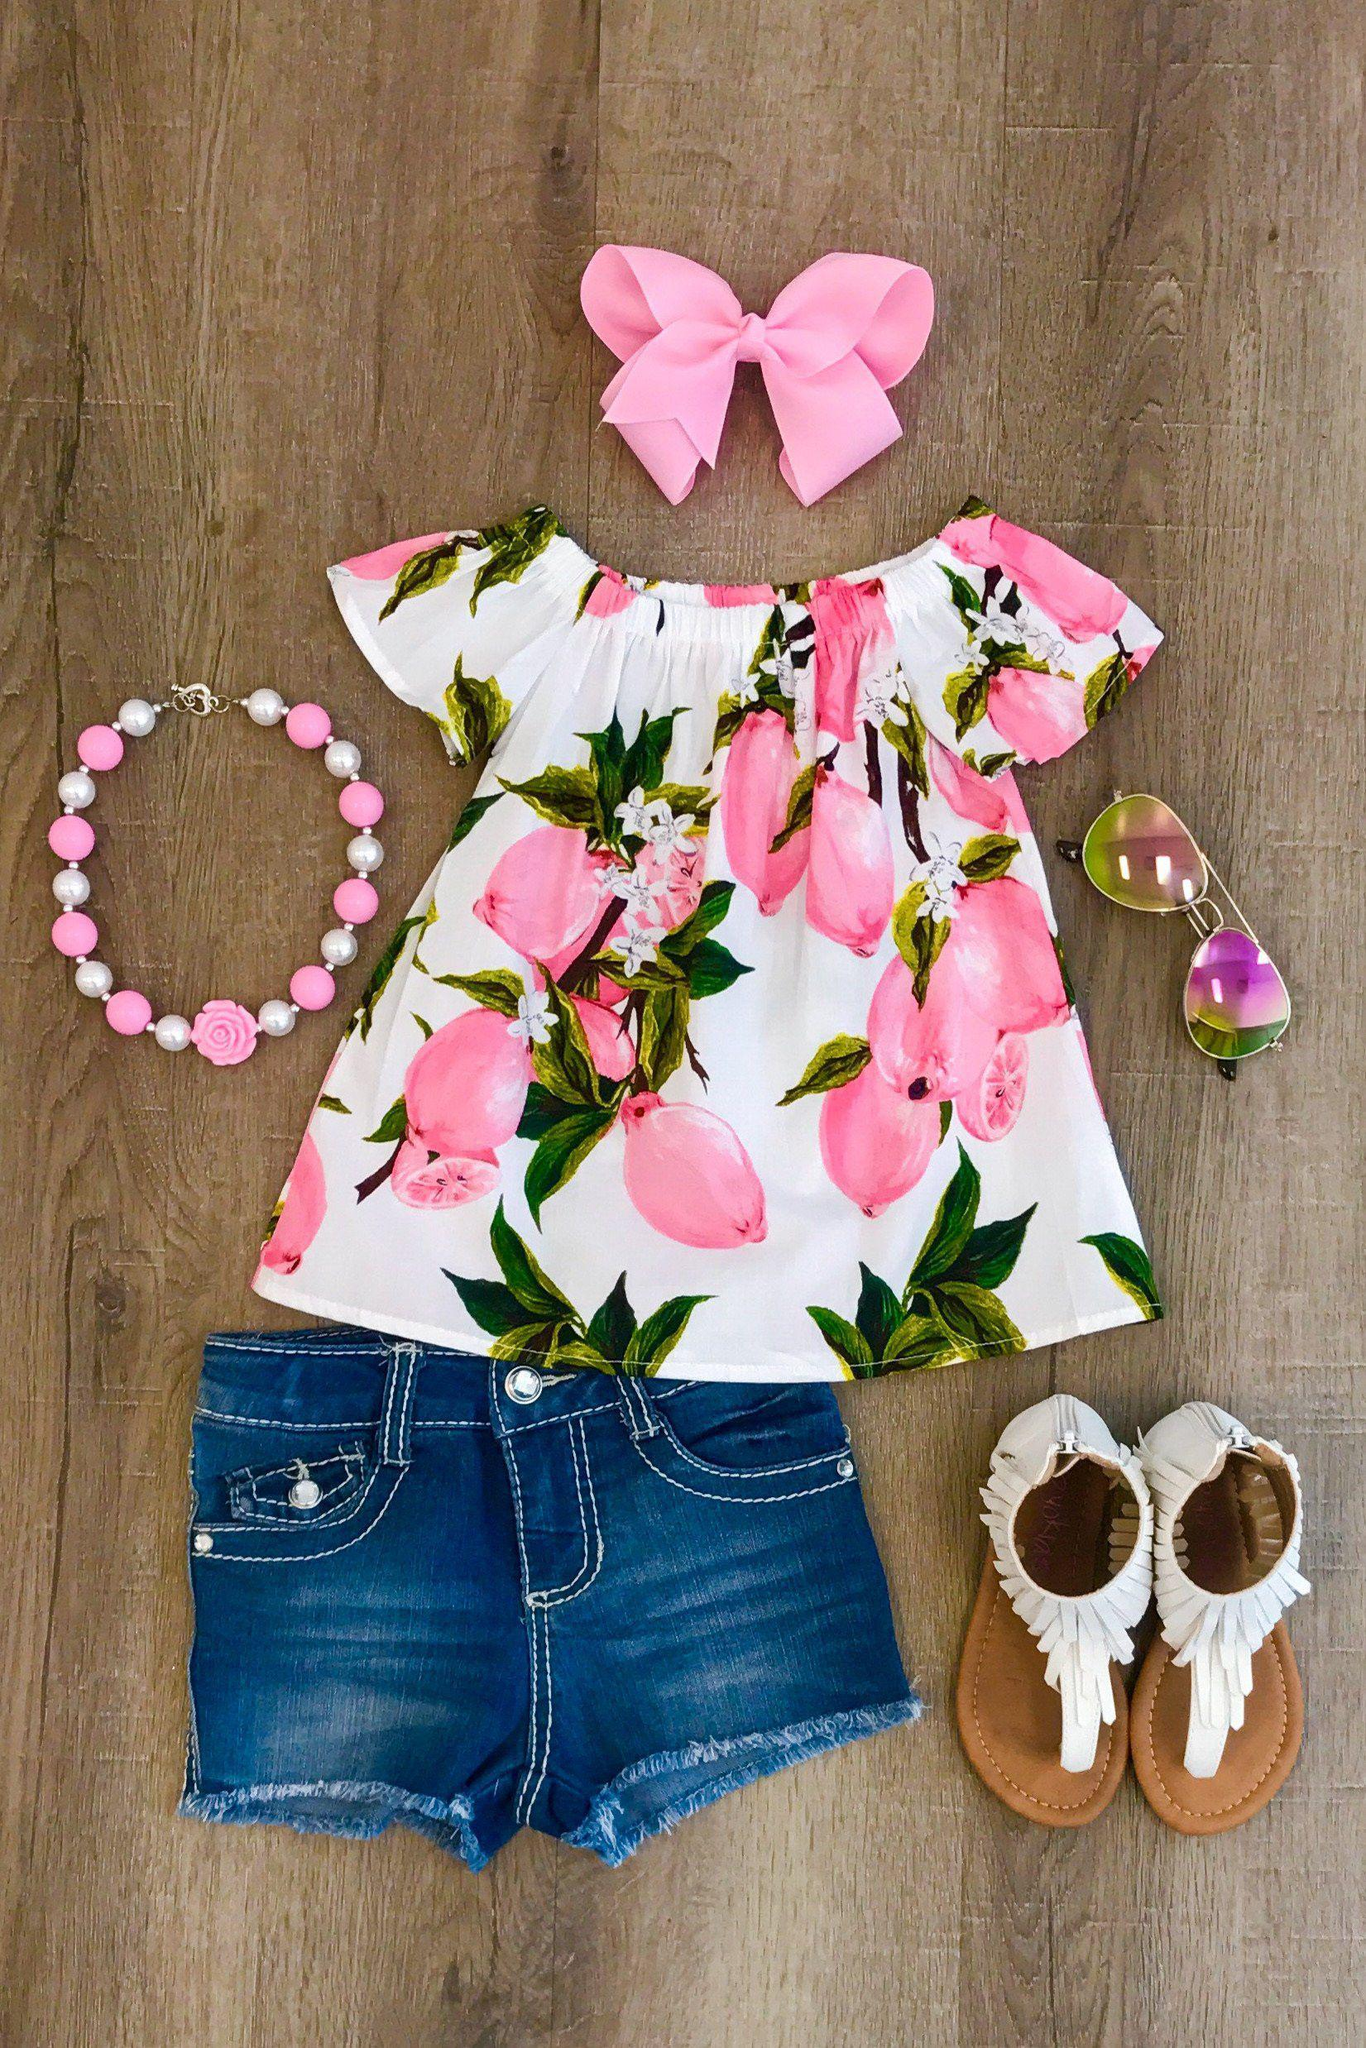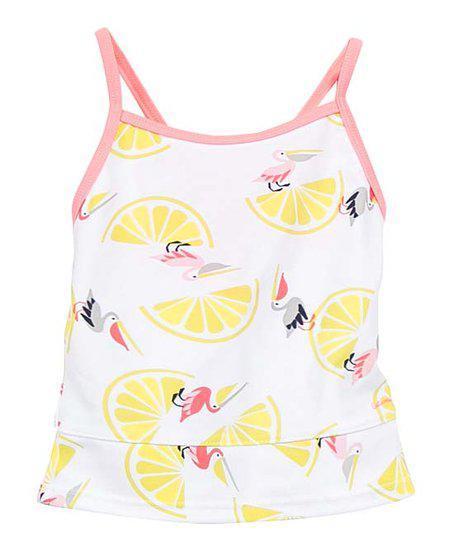The first image is the image on the left, the second image is the image on the right. Considering the images on both sides, is "One shirt is on a hanger." valid? Answer yes or no. No. The first image is the image on the left, the second image is the image on the right. Examine the images to the left and right. Is the description "Each image contains a top with a printed pattern that includes pink fruits." accurate? Answer yes or no. No. 